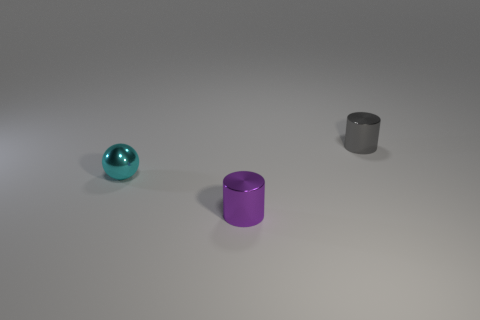There is a cyan shiny object left of the small cylinder that is in front of the gray metal thing; what shape is it? The cyan shiny object positioned to the left of the small cylinder, which in turn is situated in front of the gray metallic item, is spherical in shape—exhibiting the classic round, smooth contours of a sphere. 